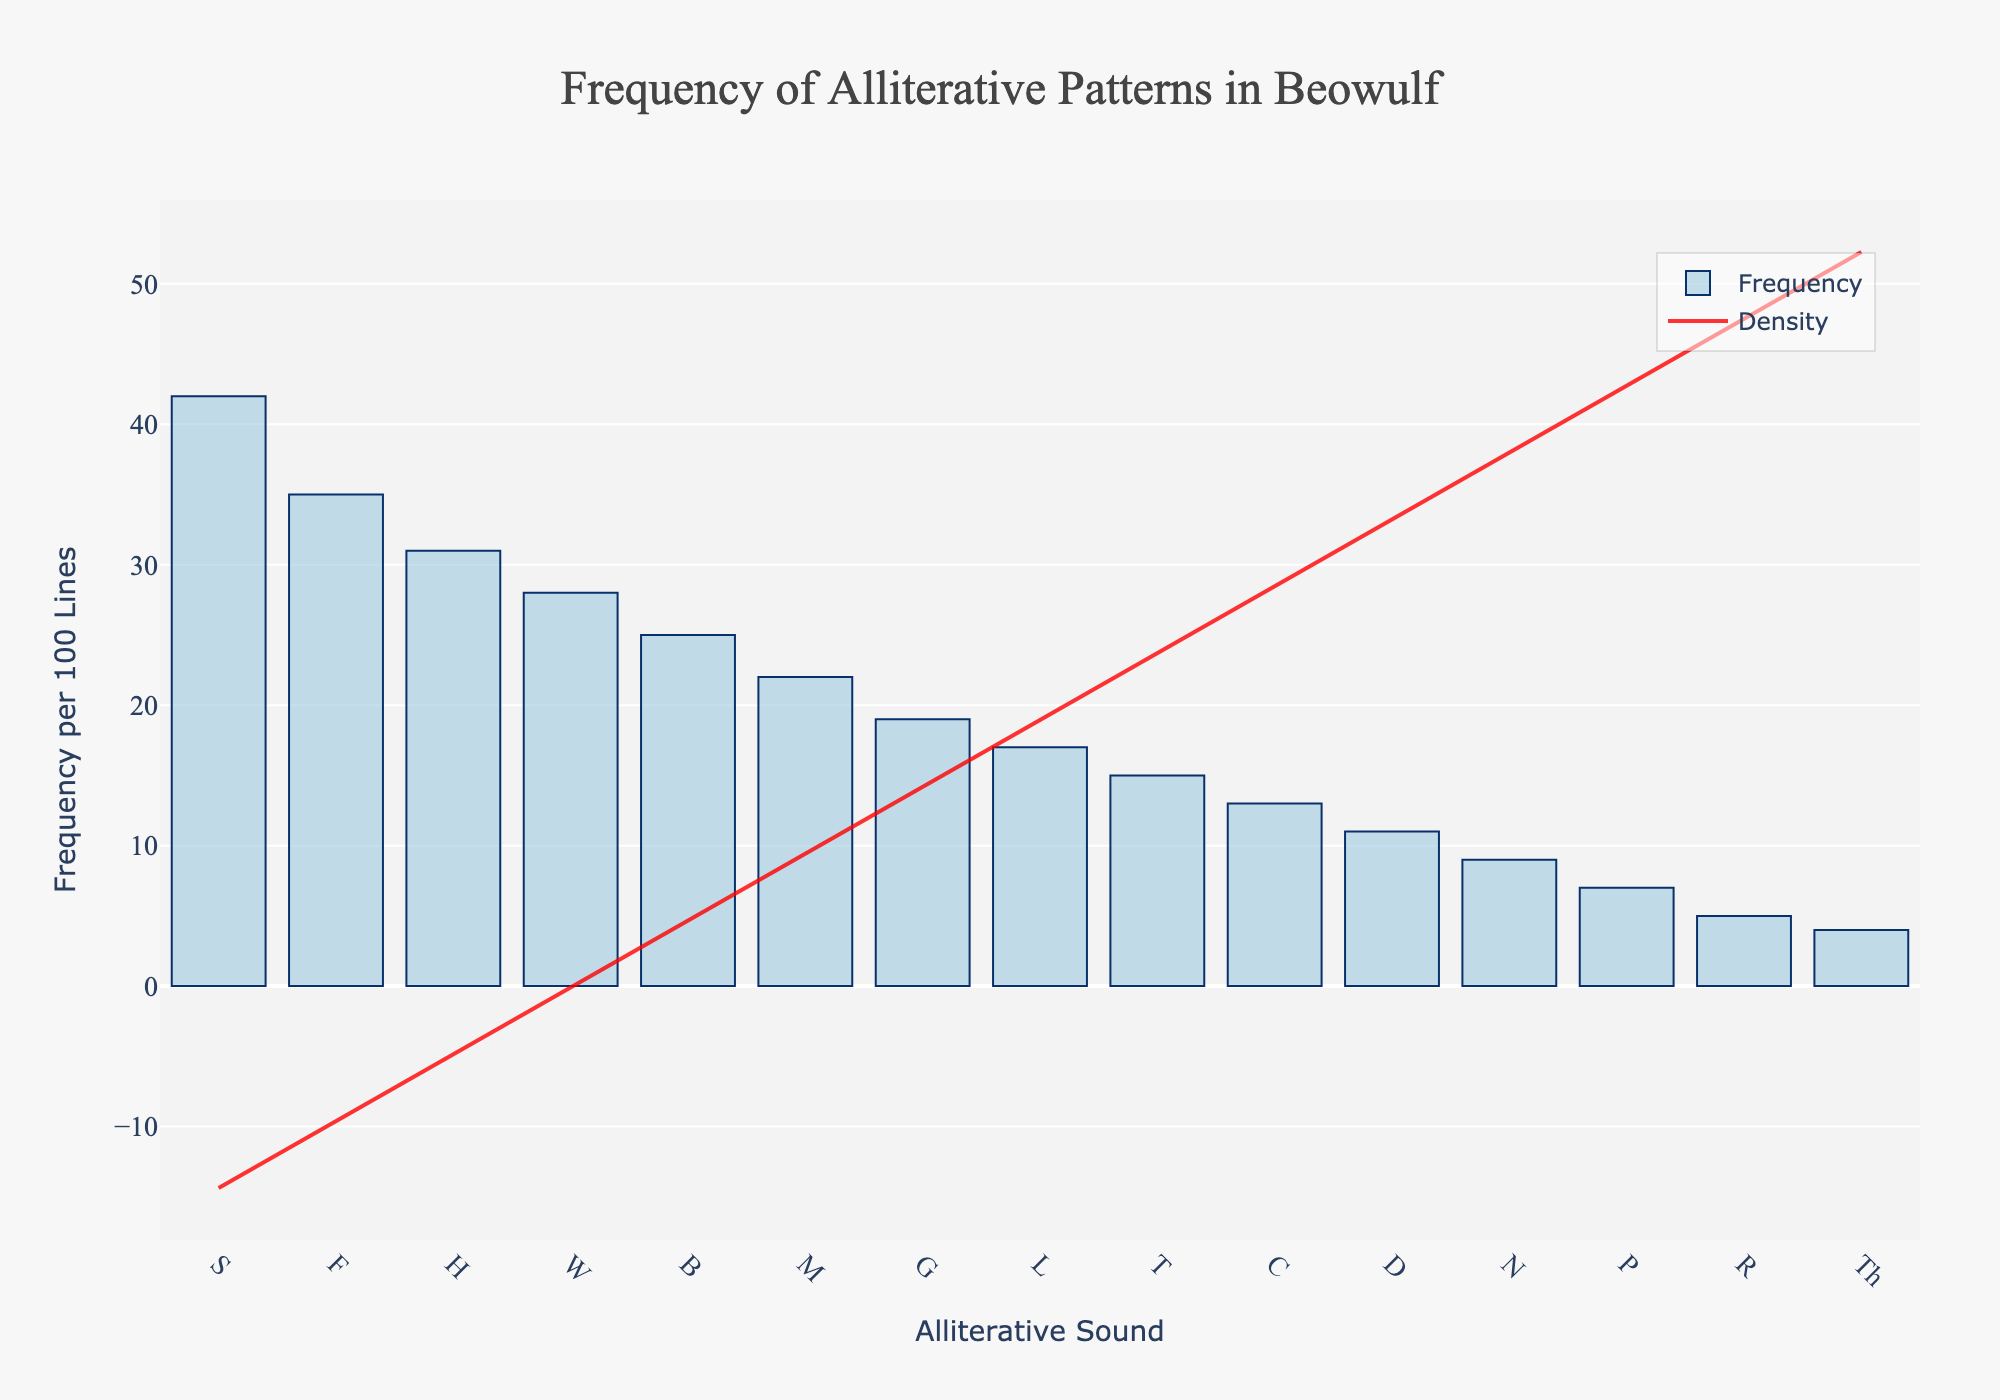What is the title of the figure? The title is typically located at the top center of the figure and helps to understand the primary focus of the plot. In this case, the title is explicitly mentioned in the layout part of the code.
Answer: Frequency of Alliterative Patterns in Beowulf What does the x-axis represent? The x-axis label is located at the bottom of the figure. From the layout code provided, it's clear that it represents "Alliterative Sound".
Answer: Alliterative Sound Which alliterative sound has the highest frequency? To determine this, we look for the highest bar on the histogram, which corresponds to the value of the "Frequency_per_100_Lines". From the data provided, 'S' has the highest frequency with 42 occurrences.
Answer: S What colors are used in the histogram and KDE trace? The histogram bars are colored light blue with a dark blue outline, and the KDE curve is colored red. These colors help differentiate between the histogram and the density curve.
Answer: Light blue and red How does the frequency of 'H' compare to that of 'G'? To compare frequencies, refer to the heights of the bars for 'H' and 'G'. 'H' has a frequency of 31 per 100 lines, whereas 'G' has a frequency of 19 per 100 lines. Therefore, 'H' is higher.
Answer: H > G What does the KDE (red line) represent in the plot? The KDE (Kernel Density Estimate) represents the density of the data points. It's a smooth curve that estimates the probability density function of a random variable, providing a continuous alternative to the histogram's discrete bars.
Answer: Density of frequencies How many alliterative sounds have a frequency between 10 and 20 per 100 lines? From the histogram, count the number of bars where the frequency lies between 10 and 20. These sounds are C, D, and N with frequencies of 13, 11, and 9 respectively.
Answer: 3 What is the combined frequency of 'M', 'B', and 'W'? Add the frequencies of 'M' (22), 'B' (25), and 'W' (28). The combined frequency is 22 + 25 + 28 = 75 per 100 lines.
Answer: 75 Which alliterative sounds have a frequency lower than 'L'? 'L' has a frequency of 17 per 100 lines. Sounds with a lower frequency are T, C, D, N, P, R, and Th.
Answer: T, C, D, N, P, R, Th 